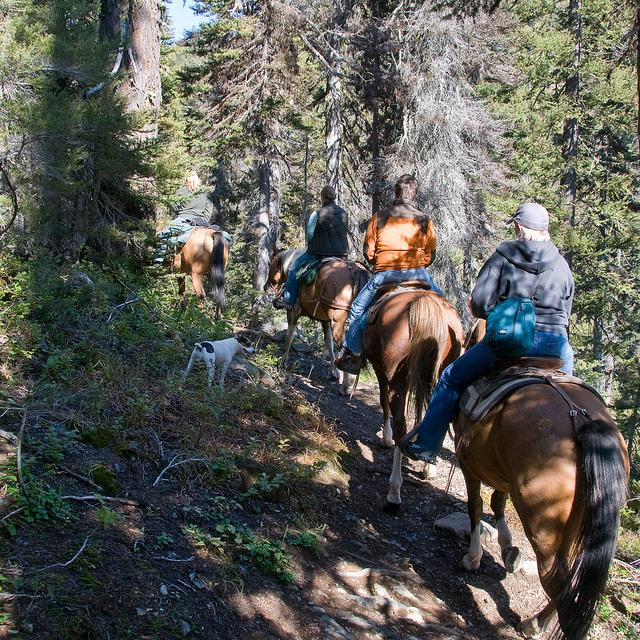Why are some trees here leafless? Please explain your reasoning. they're dead. The trees are dying. 